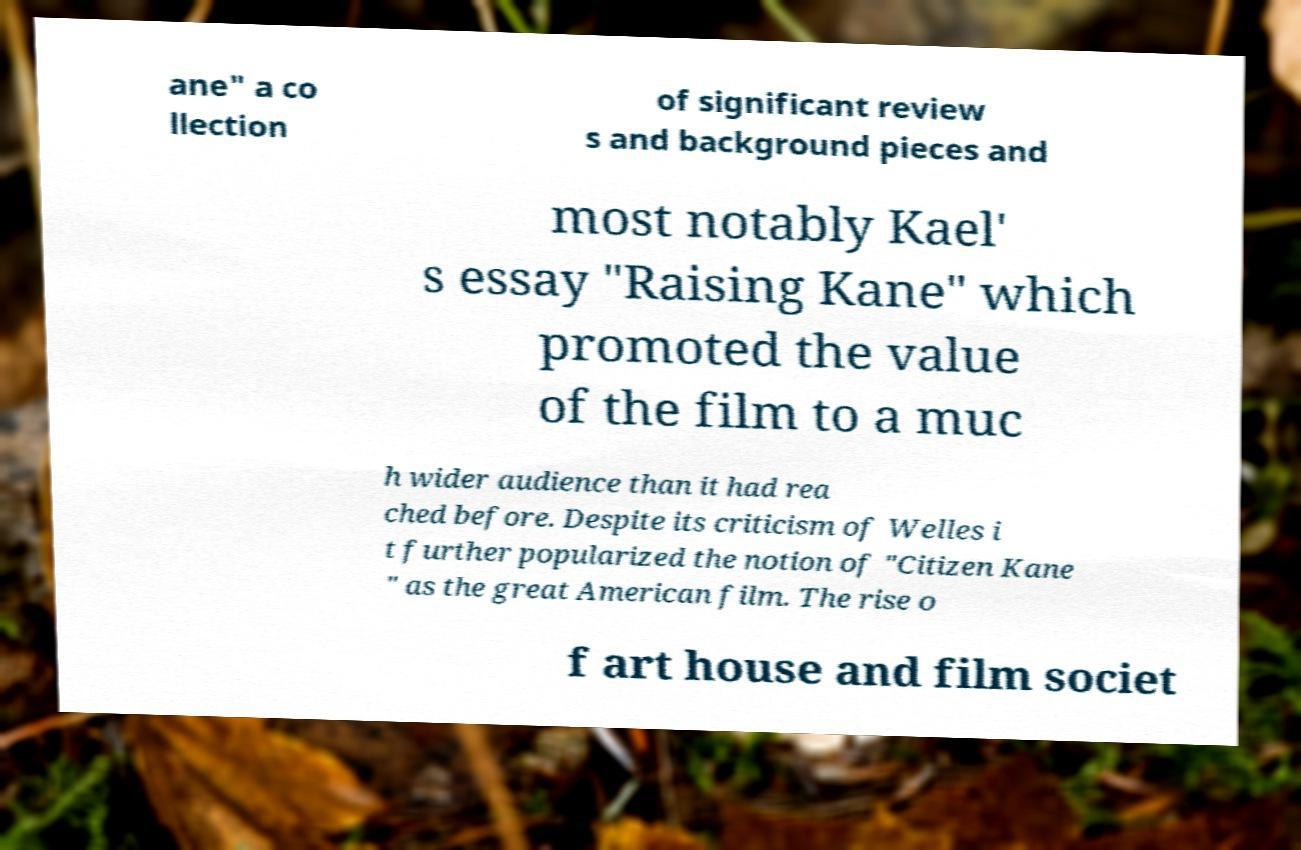I need the written content from this picture converted into text. Can you do that? ane" a co llection of significant review s and background pieces and most notably Kael' s essay "Raising Kane" which promoted the value of the film to a muc h wider audience than it had rea ched before. Despite its criticism of Welles i t further popularized the notion of "Citizen Kane " as the great American film. The rise o f art house and film societ 